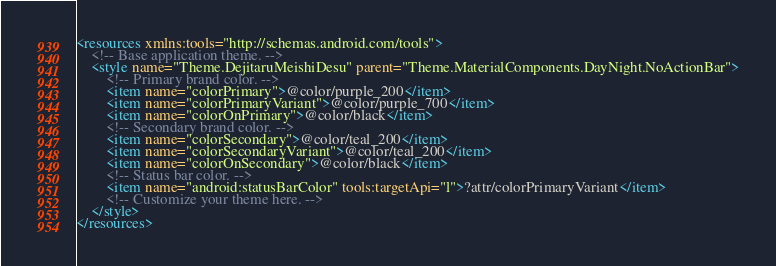<code> <loc_0><loc_0><loc_500><loc_500><_XML_><resources xmlns:tools="http://schemas.android.com/tools">
    <!-- Base application theme. -->
    <style name="Theme.DejitaruMeishiDesu" parent="Theme.MaterialComponents.DayNight.NoActionBar">
        <!-- Primary brand color. -->
        <item name="colorPrimary">@color/purple_200</item>
        <item name="colorPrimaryVariant">@color/purple_700</item>
        <item name="colorOnPrimary">@color/black</item>
        <!-- Secondary brand color. -->
        <item name="colorSecondary">@color/teal_200</item>
        <item name="colorSecondaryVariant">@color/teal_200</item>
        <item name="colorOnSecondary">@color/black</item>
        <!-- Status bar color. -->
        <item name="android:statusBarColor" tools:targetApi="l">?attr/colorPrimaryVariant</item>
        <!-- Customize your theme here. -->
    </style>
</resources></code> 